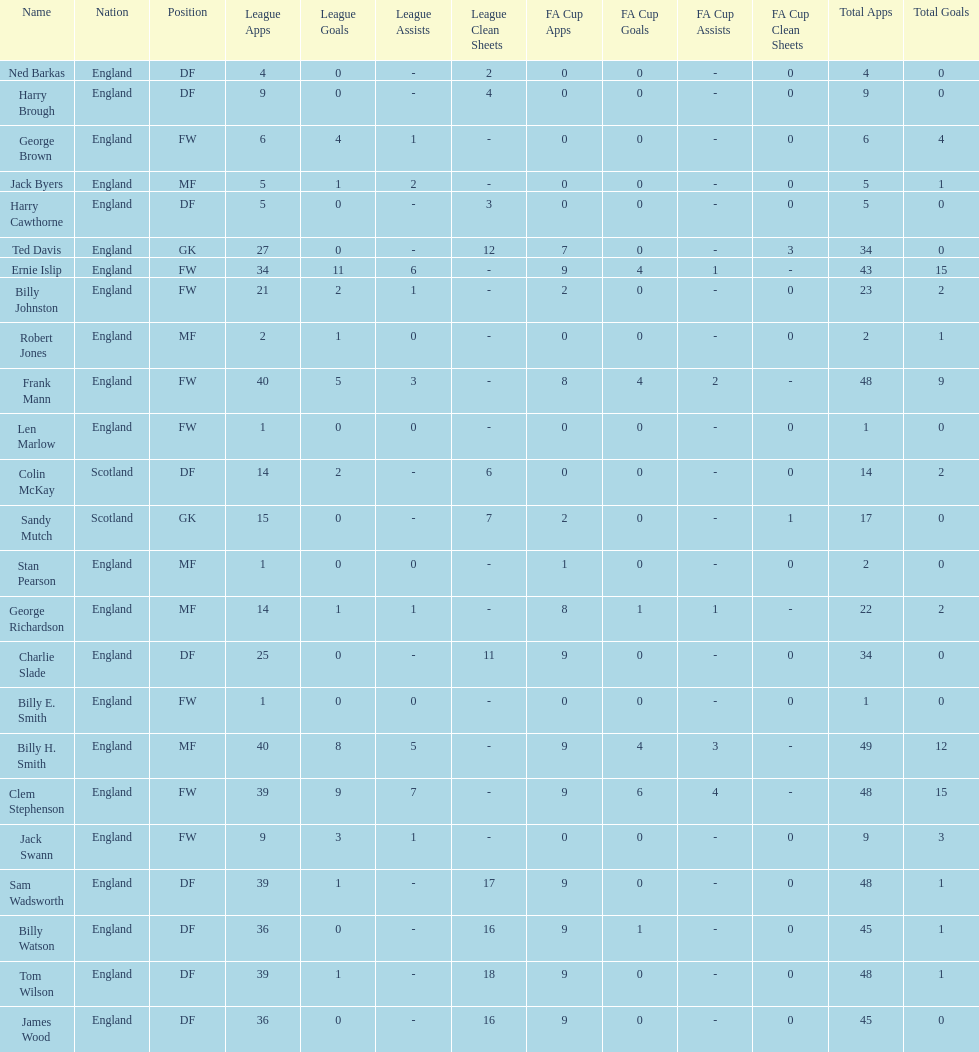Which position is listed the least amount of times on this chart? GK. 